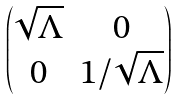<formula> <loc_0><loc_0><loc_500><loc_500>\begin{pmatrix} \sqrt { \Lambda } & 0 \\ 0 & 1 / \sqrt { \Lambda } \end{pmatrix}</formula> 